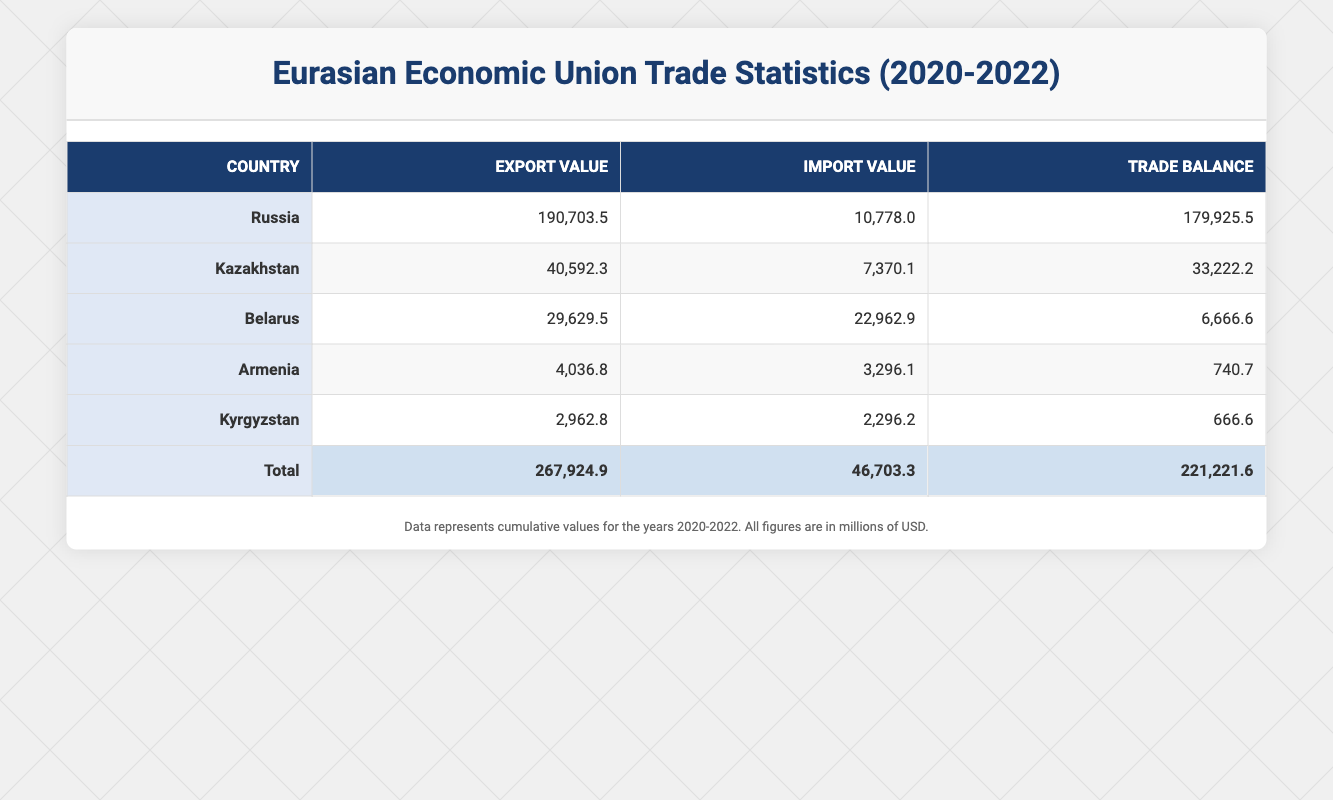What was Russia's export value in 2021? The table shows that Russia's export value in 2021 for the Energy sector was 62345.6 million USD.
Answer: 62345.6 million USD Which country had the highest trade balance in 2022? From the table, Russia had a trade balance of 66334.4 million USD in 2022, which is more than any other country listed.
Answer: Russia How much did Kazakhstan import in total from 2020 to 2022? To find Kazakhstan's total imports, sum the import values for the years: 7343.1 + 2456.7 + 2567.8 = 12367.6 million USD.
Answer: 12367.6 million USD Did Belarus have a positive trade balance in 2021? Looking at the table, Belarus' trade balance in 2021 was 2222.2 million USD, which is positive.
Answer: Yes What is the average export value of the Agriculture sector across the three years? The export values for Armenia (2020 to 2022) are: 1234.5 + 1345.6 + 1456.7 = 4036.8 million USD. There are 3 data points, so the average is 4036.8 / 3 = 1345.6 million USD.
Answer: 1345.6 million USD How much higher was Russia's export value in 2022 compared to 2020? In 2022, Russia's export value was 70123.4 million USD and in 2020 it was 58234.5 million USD. The difference is 70123.4 - 58234.5 = 11888.9 million USD.
Answer: 11888.9 million USD Which member country had the lowest export value in 2020? By examining the table, Kyrgyzstan had the lowest export value in 2020 with 876.5 million USD in the Textiles sector.
Answer: Kyrgyzstan Is the total trade balance for the Eurasian Economic Union over the three years positive? Summing the trade balances for all countries, we find: 179925.5 (Russia) + 33222.2 (Kazakhstan) + 6666.6 (Belarus) + 740.7 (Armenia) + 666.6 (Kyrgyzstan) = 221221.6 million USD, which is indeed positive.
Answer: Yes 